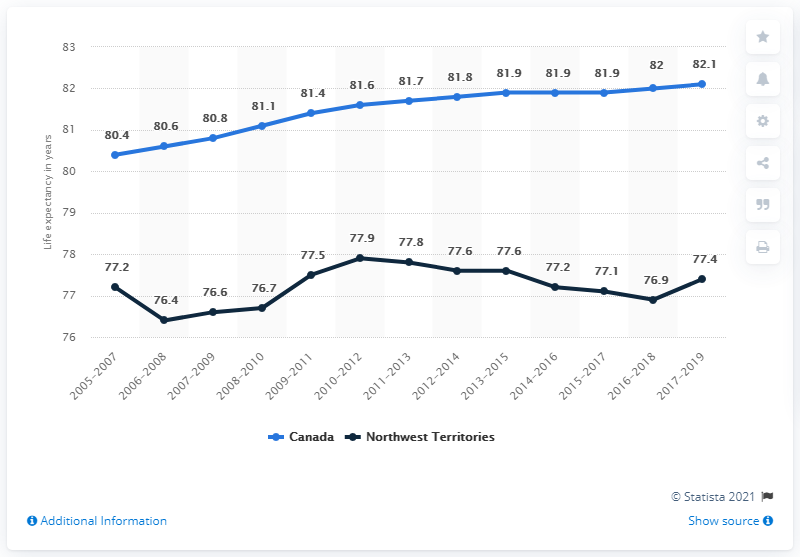Identify some key points in this picture. To calculate the average price of properties in Canada, we first add the first data point and the last data point and divide the result by 10. This gives us an average price of 16.25. Blue bar data refers to data related to Canada. 